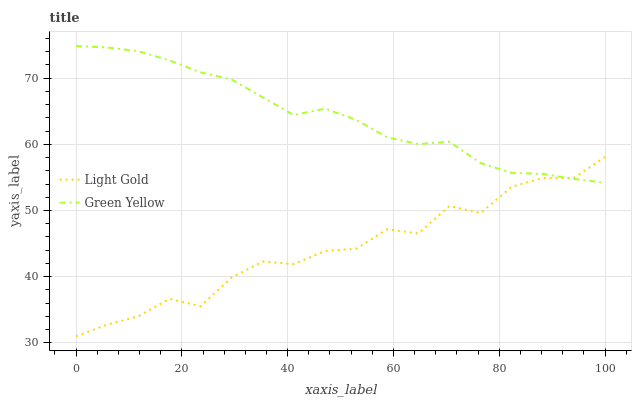Does Light Gold have the maximum area under the curve?
Answer yes or no. No. Is Light Gold the smoothest?
Answer yes or no. No. Does Light Gold have the highest value?
Answer yes or no. No. 